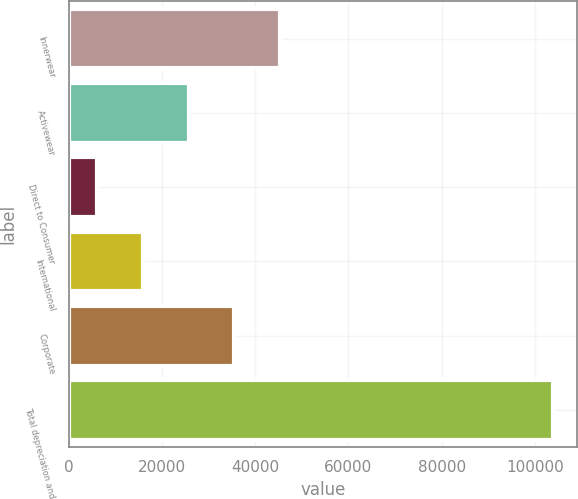<chart> <loc_0><loc_0><loc_500><loc_500><bar_chart><fcel>Innerwear<fcel>Activewear<fcel>Direct to Consumer<fcel>International<fcel>Corporate<fcel>Total depreciation and<nl><fcel>45223.6<fcel>25663.8<fcel>6104<fcel>15883.9<fcel>35443.7<fcel>103903<nl></chart> 